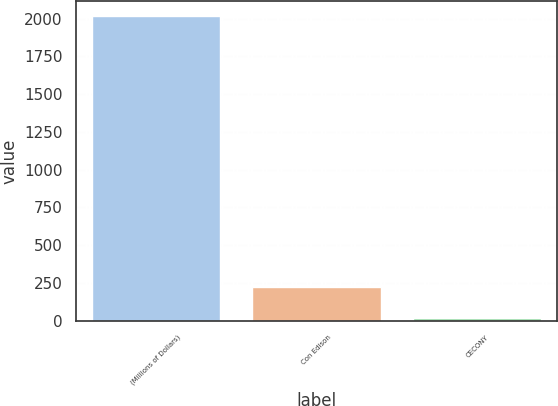Convert chart to OTSL. <chart><loc_0><loc_0><loc_500><loc_500><bar_chart><fcel>(Millions of Dollars)<fcel>Con Edison<fcel>CECONY<nl><fcel>2014<fcel>219.4<fcel>20<nl></chart> 